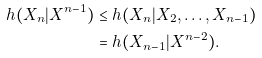<formula> <loc_0><loc_0><loc_500><loc_500>h ( X _ { n } | X ^ { n - 1 } ) & \leq h ( X _ { n } | X _ { 2 } , \dots , X _ { n - 1 } ) \\ & = h ( X _ { n - 1 } | X ^ { n - 2 } ) .</formula> 